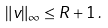<formula> <loc_0><loc_0><loc_500><loc_500>\| v \| _ { \infty } \leq R + 1 \, .</formula> 